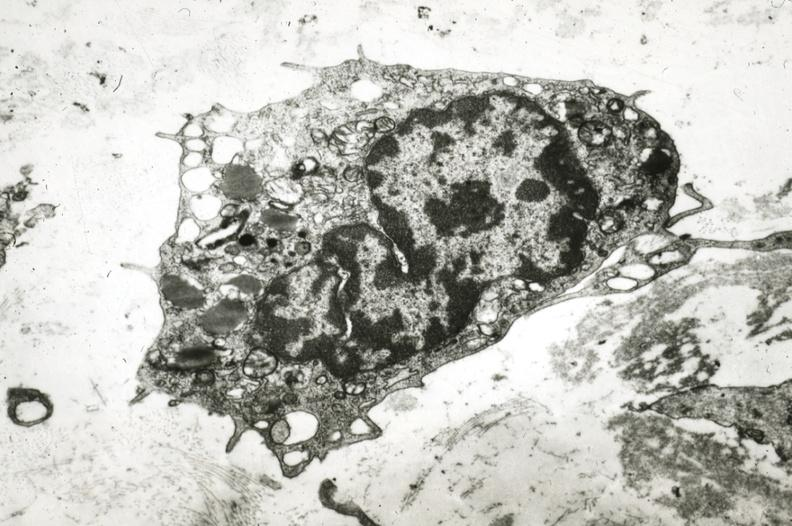s cardiovascular present?
Answer the question using a single word or phrase. Yes 